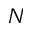<formula> <loc_0><loc_0><loc_500><loc_500>N</formula> 